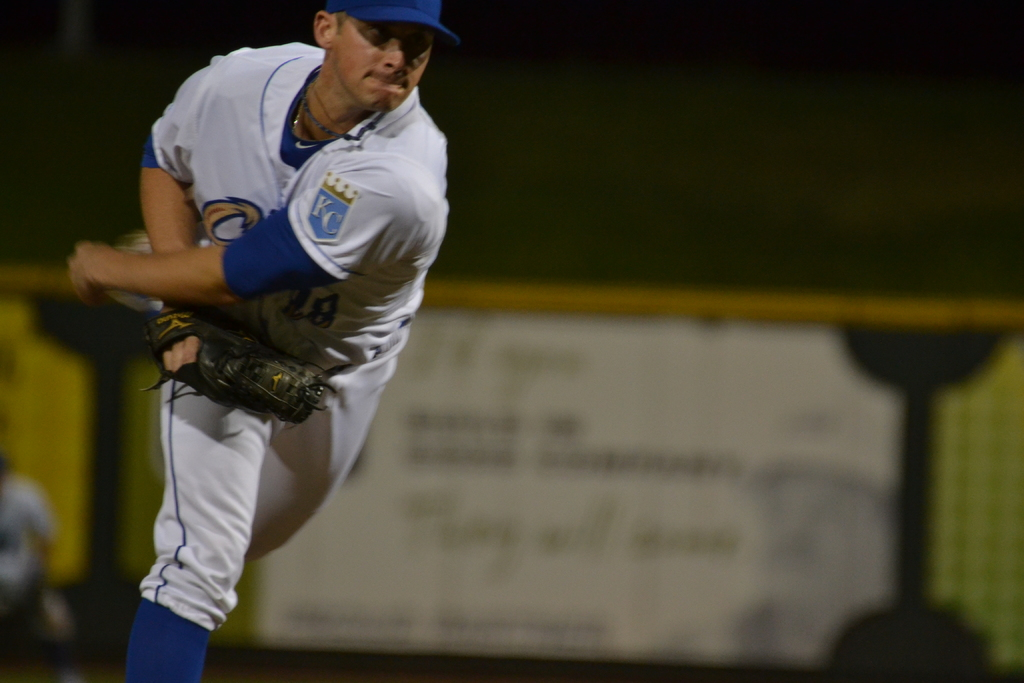What emotions might the athlete be experiencing in this moment? The athlete likely feels a mix of intense concentration and pressure, possibly mixed with excitement, as he executes a critical pitch during a game. 